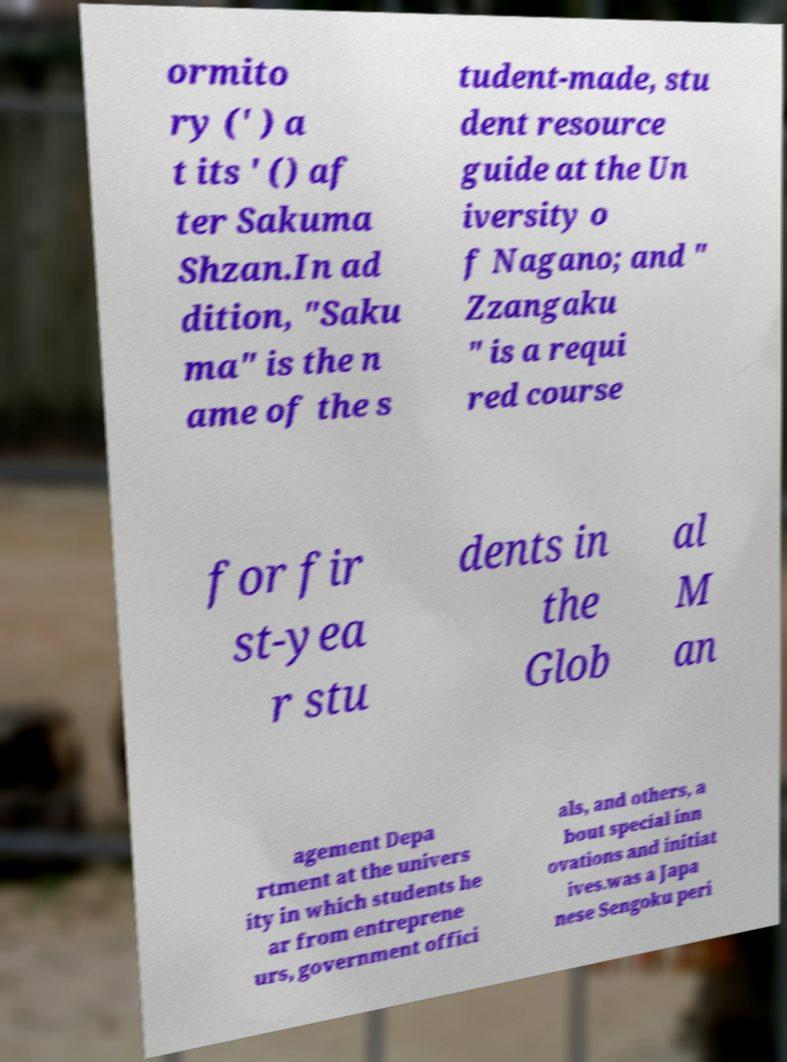Could you extract and type out the text from this image? ormito ry (' ) a t its ' () af ter Sakuma Shzan.In ad dition, "Saku ma" is the n ame of the s tudent-made, stu dent resource guide at the Un iversity o f Nagano; and " Zzangaku " is a requi red course for fir st-yea r stu dents in the Glob al M an agement Depa rtment at the univers ity in which students he ar from entreprene urs, government offici als, and others, a bout special inn ovations and initiat ives.was a Japa nese Sengoku peri 